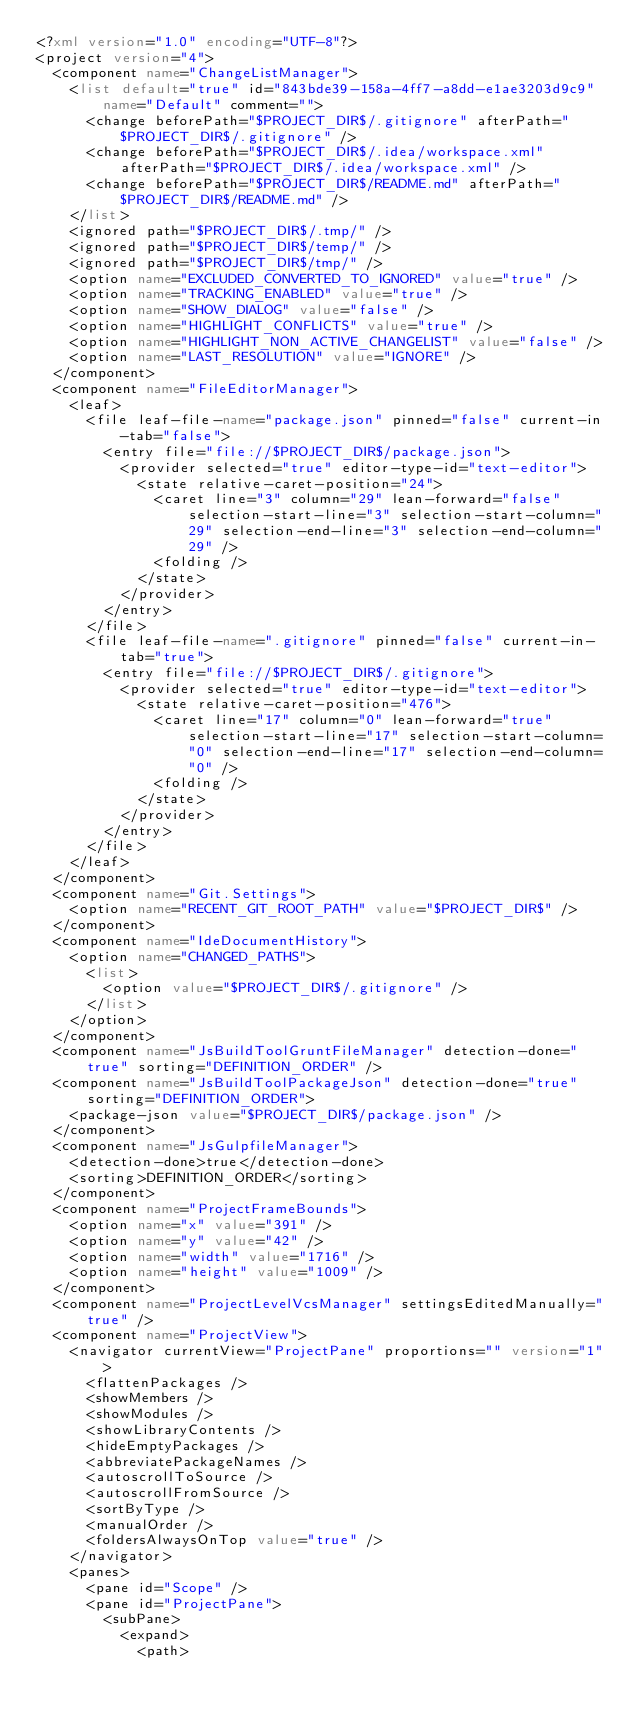<code> <loc_0><loc_0><loc_500><loc_500><_XML_><?xml version="1.0" encoding="UTF-8"?>
<project version="4">
  <component name="ChangeListManager">
    <list default="true" id="843bde39-158a-4ff7-a8dd-e1ae3203d9c9" name="Default" comment="">
      <change beforePath="$PROJECT_DIR$/.gitignore" afterPath="$PROJECT_DIR$/.gitignore" />
      <change beforePath="$PROJECT_DIR$/.idea/workspace.xml" afterPath="$PROJECT_DIR$/.idea/workspace.xml" />
      <change beforePath="$PROJECT_DIR$/README.md" afterPath="$PROJECT_DIR$/README.md" />
    </list>
    <ignored path="$PROJECT_DIR$/.tmp/" />
    <ignored path="$PROJECT_DIR$/temp/" />
    <ignored path="$PROJECT_DIR$/tmp/" />
    <option name="EXCLUDED_CONVERTED_TO_IGNORED" value="true" />
    <option name="TRACKING_ENABLED" value="true" />
    <option name="SHOW_DIALOG" value="false" />
    <option name="HIGHLIGHT_CONFLICTS" value="true" />
    <option name="HIGHLIGHT_NON_ACTIVE_CHANGELIST" value="false" />
    <option name="LAST_RESOLUTION" value="IGNORE" />
  </component>
  <component name="FileEditorManager">
    <leaf>
      <file leaf-file-name="package.json" pinned="false" current-in-tab="false">
        <entry file="file://$PROJECT_DIR$/package.json">
          <provider selected="true" editor-type-id="text-editor">
            <state relative-caret-position="24">
              <caret line="3" column="29" lean-forward="false" selection-start-line="3" selection-start-column="29" selection-end-line="3" selection-end-column="29" />
              <folding />
            </state>
          </provider>
        </entry>
      </file>
      <file leaf-file-name=".gitignore" pinned="false" current-in-tab="true">
        <entry file="file://$PROJECT_DIR$/.gitignore">
          <provider selected="true" editor-type-id="text-editor">
            <state relative-caret-position="476">
              <caret line="17" column="0" lean-forward="true" selection-start-line="17" selection-start-column="0" selection-end-line="17" selection-end-column="0" />
              <folding />
            </state>
          </provider>
        </entry>
      </file>
    </leaf>
  </component>
  <component name="Git.Settings">
    <option name="RECENT_GIT_ROOT_PATH" value="$PROJECT_DIR$" />
  </component>
  <component name="IdeDocumentHistory">
    <option name="CHANGED_PATHS">
      <list>
        <option value="$PROJECT_DIR$/.gitignore" />
      </list>
    </option>
  </component>
  <component name="JsBuildToolGruntFileManager" detection-done="true" sorting="DEFINITION_ORDER" />
  <component name="JsBuildToolPackageJson" detection-done="true" sorting="DEFINITION_ORDER">
    <package-json value="$PROJECT_DIR$/package.json" />
  </component>
  <component name="JsGulpfileManager">
    <detection-done>true</detection-done>
    <sorting>DEFINITION_ORDER</sorting>
  </component>
  <component name="ProjectFrameBounds">
    <option name="x" value="391" />
    <option name="y" value="42" />
    <option name="width" value="1716" />
    <option name="height" value="1009" />
  </component>
  <component name="ProjectLevelVcsManager" settingsEditedManually="true" />
  <component name="ProjectView">
    <navigator currentView="ProjectPane" proportions="" version="1">
      <flattenPackages />
      <showMembers />
      <showModules />
      <showLibraryContents />
      <hideEmptyPackages />
      <abbreviatePackageNames />
      <autoscrollToSource />
      <autoscrollFromSource />
      <sortByType />
      <manualOrder />
      <foldersAlwaysOnTop value="true" />
    </navigator>
    <panes>
      <pane id="Scope" />
      <pane id="ProjectPane">
        <subPane>
          <expand>
            <path></code> 